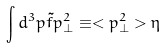Convert formula to latex. <formula><loc_0><loc_0><loc_500><loc_500>\int d ^ { 3 } p \tilde { f } p _ { \perp } ^ { 2 } \equiv < p _ { \perp } ^ { 2 } > \eta</formula> 